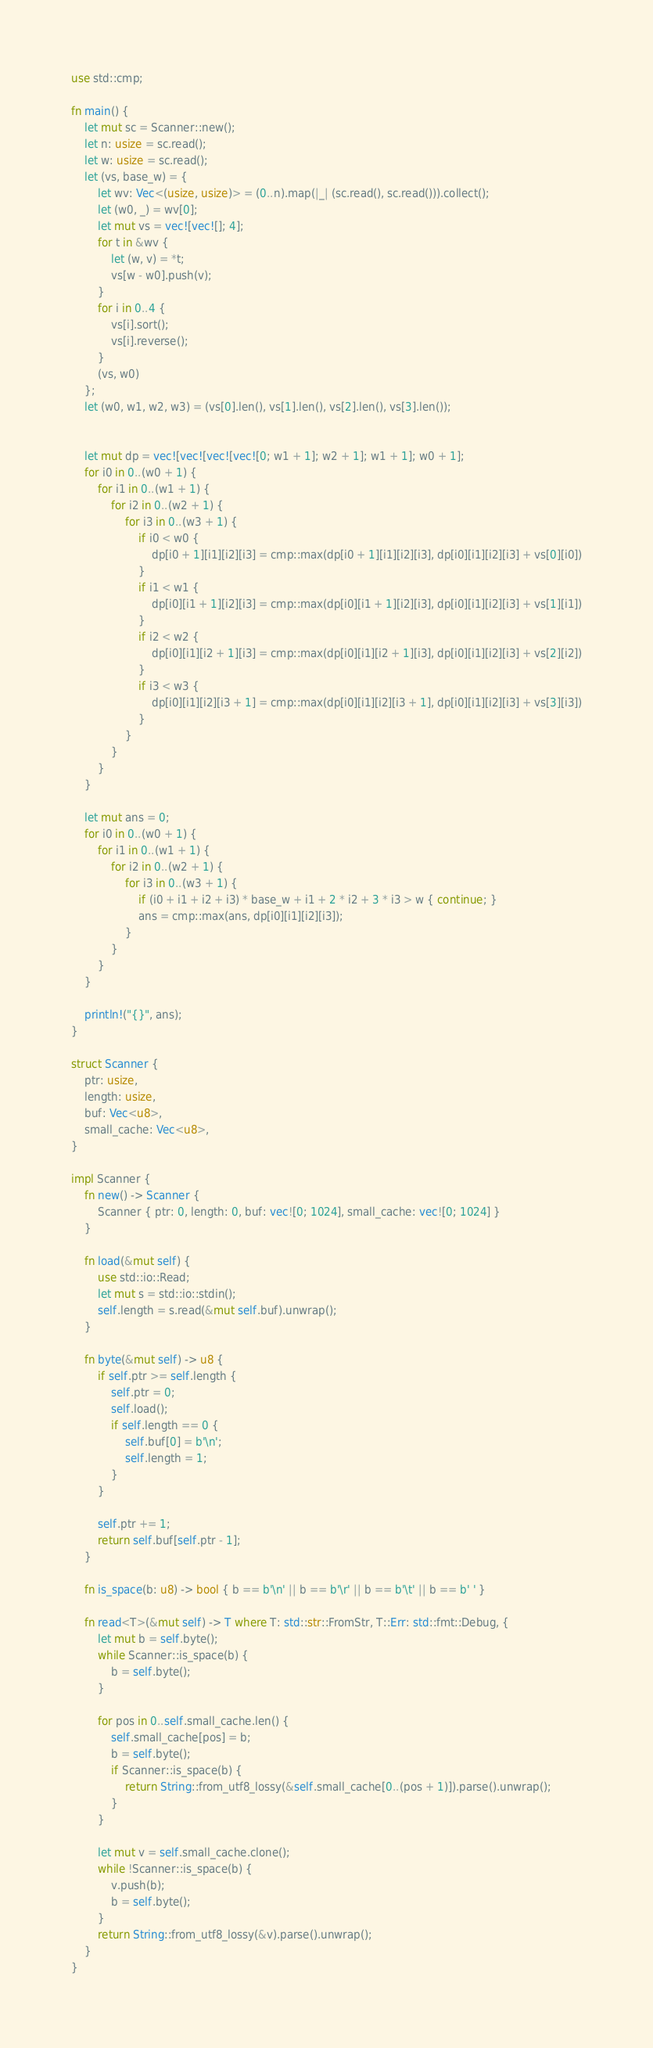Convert code to text. <code><loc_0><loc_0><loc_500><loc_500><_Rust_>use std::cmp;

fn main() {
    let mut sc = Scanner::new();
    let n: usize = sc.read();
    let w: usize = sc.read();
    let (vs, base_w) = {
        let wv: Vec<(usize, usize)> = (0..n).map(|_| (sc.read(), sc.read())).collect();
        let (w0, _) = wv[0];
        let mut vs = vec![vec![]; 4];
        for t in &wv {
            let (w, v) = *t;
            vs[w - w0].push(v);
        }
        for i in 0..4 {
            vs[i].sort();
            vs[i].reverse();
        }
        (vs, w0)
    };
    let (w0, w1, w2, w3) = (vs[0].len(), vs[1].len(), vs[2].len(), vs[3].len());


    let mut dp = vec![vec![vec![vec![0; w1 + 1]; w2 + 1]; w1 + 1]; w0 + 1];
    for i0 in 0..(w0 + 1) {
        for i1 in 0..(w1 + 1) {
            for i2 in 0..(w2 + 1) {
                for i3 in 0..(w3 + 1) {
                    if i0 < w0 {
                        dp[i0 + 1][i1][i2][i3] = cmp::max(dp[i0 + 1][i1][i2][i3], dp[i0][i1][i2][i3] + vs[0][i0])
                    }
                    if i1 < w1 {
                        dp[i0][i1 + 1][i2][i3] = cmp::max(dp[i0][i1 + 1][i2][i3], dp[i0][i1][i2][i3] + vs[1][i1])
                    }
                    if i2 < w2 {
                        dp[i0][i1][i2 + 1][i3] = cmp::max(dp[i0][i1][i2 + 1][i3], dp[i0][i1][i2][i3] + vs[2][i2])
                    }
                    if i3 < w3 {
                        dp[i0][i1][i2][i3 + 1] = cmp::max(dp[i0][i1][i2][i3 + 1], dp[i0][i1][i2][i3] + vs[3][i3])
                    }
                }
            }
        }
    }

    let mut ans = 0;
    for i0 in 0..(w0 + 1) {
        for i1 in 0..(w1 + 1) {
            for i2 in 0..(w2 + 1) {
                for i3 in 0..(w3 + 1) {
                    if (i0 + i1 + i2 + i3) * base_w + i1 + 2 * i2 + 3 * i3 > w { continue; }
                    ans = cmp::max(ans, dp[i0][i1][i2][i3]);
                }
            }
        }
    }

    println!("{}", ans);
}

struct Scanner {
    ptr: usize,
    length: usize,
    buf: Vec<u8>,
    small_cache: Vec<u8>,
}

impl Scanner {
    fn new() -> Scanner {
        Scanner { ptr: 0, length: 0, buf: vec![0; 1024], small_cache: vec![0; 1024] }
    }

    fn load(&mut self) {
        use std::io::Read;
        let mut s = std::io::stdin();
        self.length = s.read(&mut self.buf).unwrap();
    }

    fn byte(&mut self) -> u8 {
        if self.ptr >= self.length {
            self.ptr = 0;
            self.load();
            if self.length == 0 {
                self.buf[0] = b'\n';
                self.length = 1;
            }
        }

        self.ptr += 1;
        return self.buf[self.ptr - 1];
    }

    fn is_space(b: u8) -> bool { b == b'\n' || b == b'\r' || b == b'\t' || b == b' ' }

    fn read<T>(&mut self) -> T where T: std::str::FromStr, T::Err: std::fmt::Debug, {
        let mut b = self.byte();
        while Scanner::is_space(b) {
            b = self.byte();
        }

        for pos in 0..self.small_cache.len() {
            self.small_cache[pos] = b;
            b = self.byte();
            if Scanner::is_space(b) {
                return String::from_utf8_lossy(&self.small_cache[0..(pos + 1)]).parse().unwrap();
            }
        }

        let mut v = self.small_cache.clone();
        while !Scanner::is_space(b) {
            v.push(b);
            b = self.byte();
        }
        return String::from_utf8_lossy(&v).parse().unwrap();
    }
}

</code> 